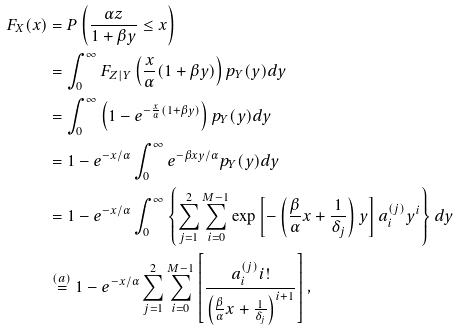<formula> <loc_0><loc_0><loc_500><loc_500>F _ { X } ( x ) & = P \left ( \frac { \alpha { z } } { 1 + \beta { y } } \leq { x } \right ) \\ & = \int _ { 0 } ^ { \infty } { F } _ { Z | Y } \left ( \frac { x } { \alpha } ( 1 + \beta { y } ) \right ) p _ { Y } ( y ) d y \\ & = \int _ { 0 } ^ { \infty } \left ( 1 - e ^ { - \frac { x } { \alpha } ( 1 + \beta { y } ) } \right ) p _ { Y } ( y ) d y \\ & = 1 - e ^ { - x / \alpha } \int _ { 0 } ^ { \infty } { e } ^ { - \beta { x y } / \alpha } p _ { Y } ( y ) d y \\ & = 1 - e ^ { - x / \alpha } \int _ { 0 } ^ { \infty } \left \{ \sum _ { j = 1 } ^ { 2 } \sum _ { i = 0 } ^ { M - 1 } \exp \left [ - \left ( \frac { \beta } { \alpha } x + \frac { 1 } { \delta _ { j } } \right ) y \right ] a ^ { ( j ) } _ { i } y ^ { i } \right \} d y \\ & \stackrel { ( a ) } { = } 1 - e ^ { - x / \alpha } \sum _ { j = 1 } ^ { 2 } \sum _ { i = 0 } ^ { M - 1 } \left [ \frac { a ^ { ( j ) } _ { i } i ! } { \left ( \frac { \beta } { \alpha } x + \frac { 1 } { \delta _ { j } } \right ) ^ { i + 1 } } \right ] ,</formula> 